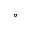<formula> <loc_0><loc_0><loc_500><loc_500>^ { \circ }</formula> 